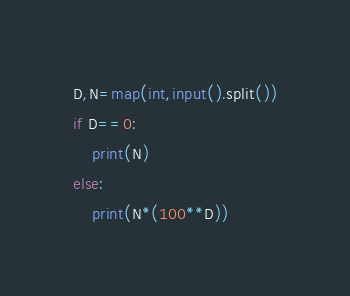<code> <loc_0><loc_0><loc_500><loc_500><_Python_>D,N=map(int,input().split())
if D==0:
    print(N)
else:
    print(N*(100**D))
</code> 